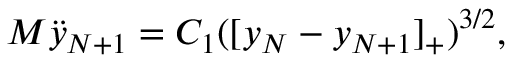Convert formula to latex. <formula><loc_0><loc_0><loc_500><loc_500>M \ddot { y } _ { N + 1 } = { C _ { 1 } } ( [ y _ { N } - y _ { N + 1 } ] _ { + } ) ^ { 3 / 2 } ,</formula> 